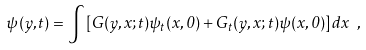<formula> <loc_0><loc_0><loc_500><loc_500>\psi ( y , t ) = \int \left [ G ( y , x ; t ) \psi _ { t } ( x , 0 ) + G _ { t } ( y , x ; t ) \psi ( x , 0 ) \right ] d x \ ,</formula> 